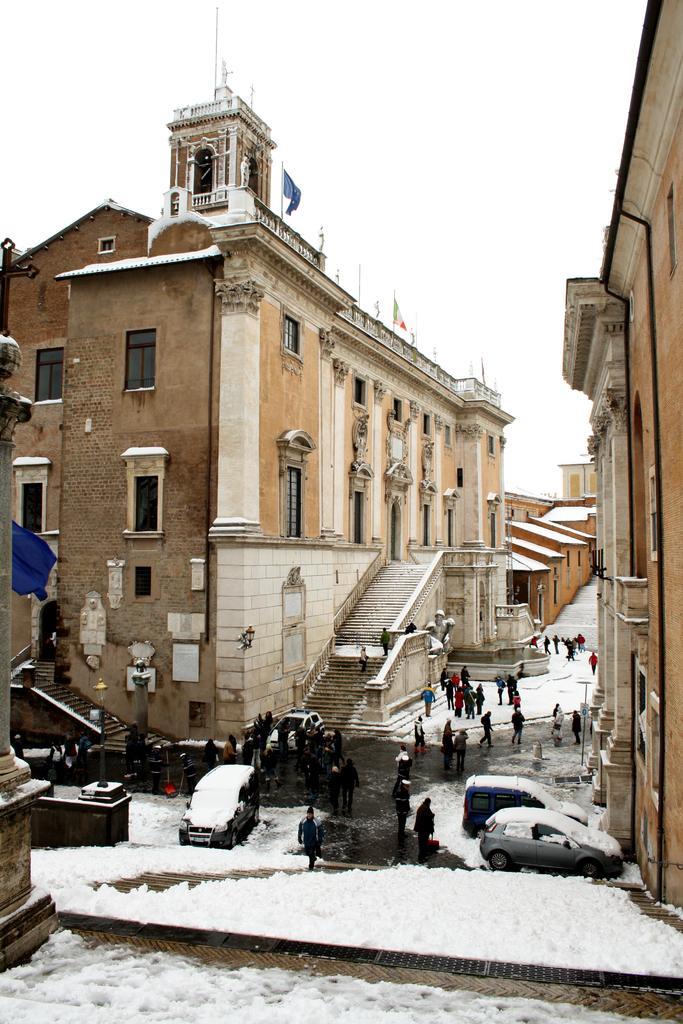Can you describe this image briefly? In this picture, there is a road between the buildings. The buildings are in brown in color with windows. Towards the left, there is a building with two staircases. Before the building, there are people moving around. At the bottom there are vehicles covered with the snow. At the bottom there is snow. On the top, there is a sky. 